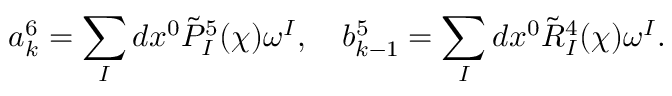<formula> <loc_0><loc_0><loc_500><loc_500>a _ { k } ^ { 6 } = \sum _ { I } d x ^ { 0 } \tilde { P } _ { I } ^ { 5 } ( \chi ) \omega ^ { I } , \quad b _ { k - 1 } ^ { 5 } = \sum _ { I } d x ^ { 0 } \tilde { R } _ { I } ^ { 4 } ( \chi ) \omega ^ { I } .</formula> 